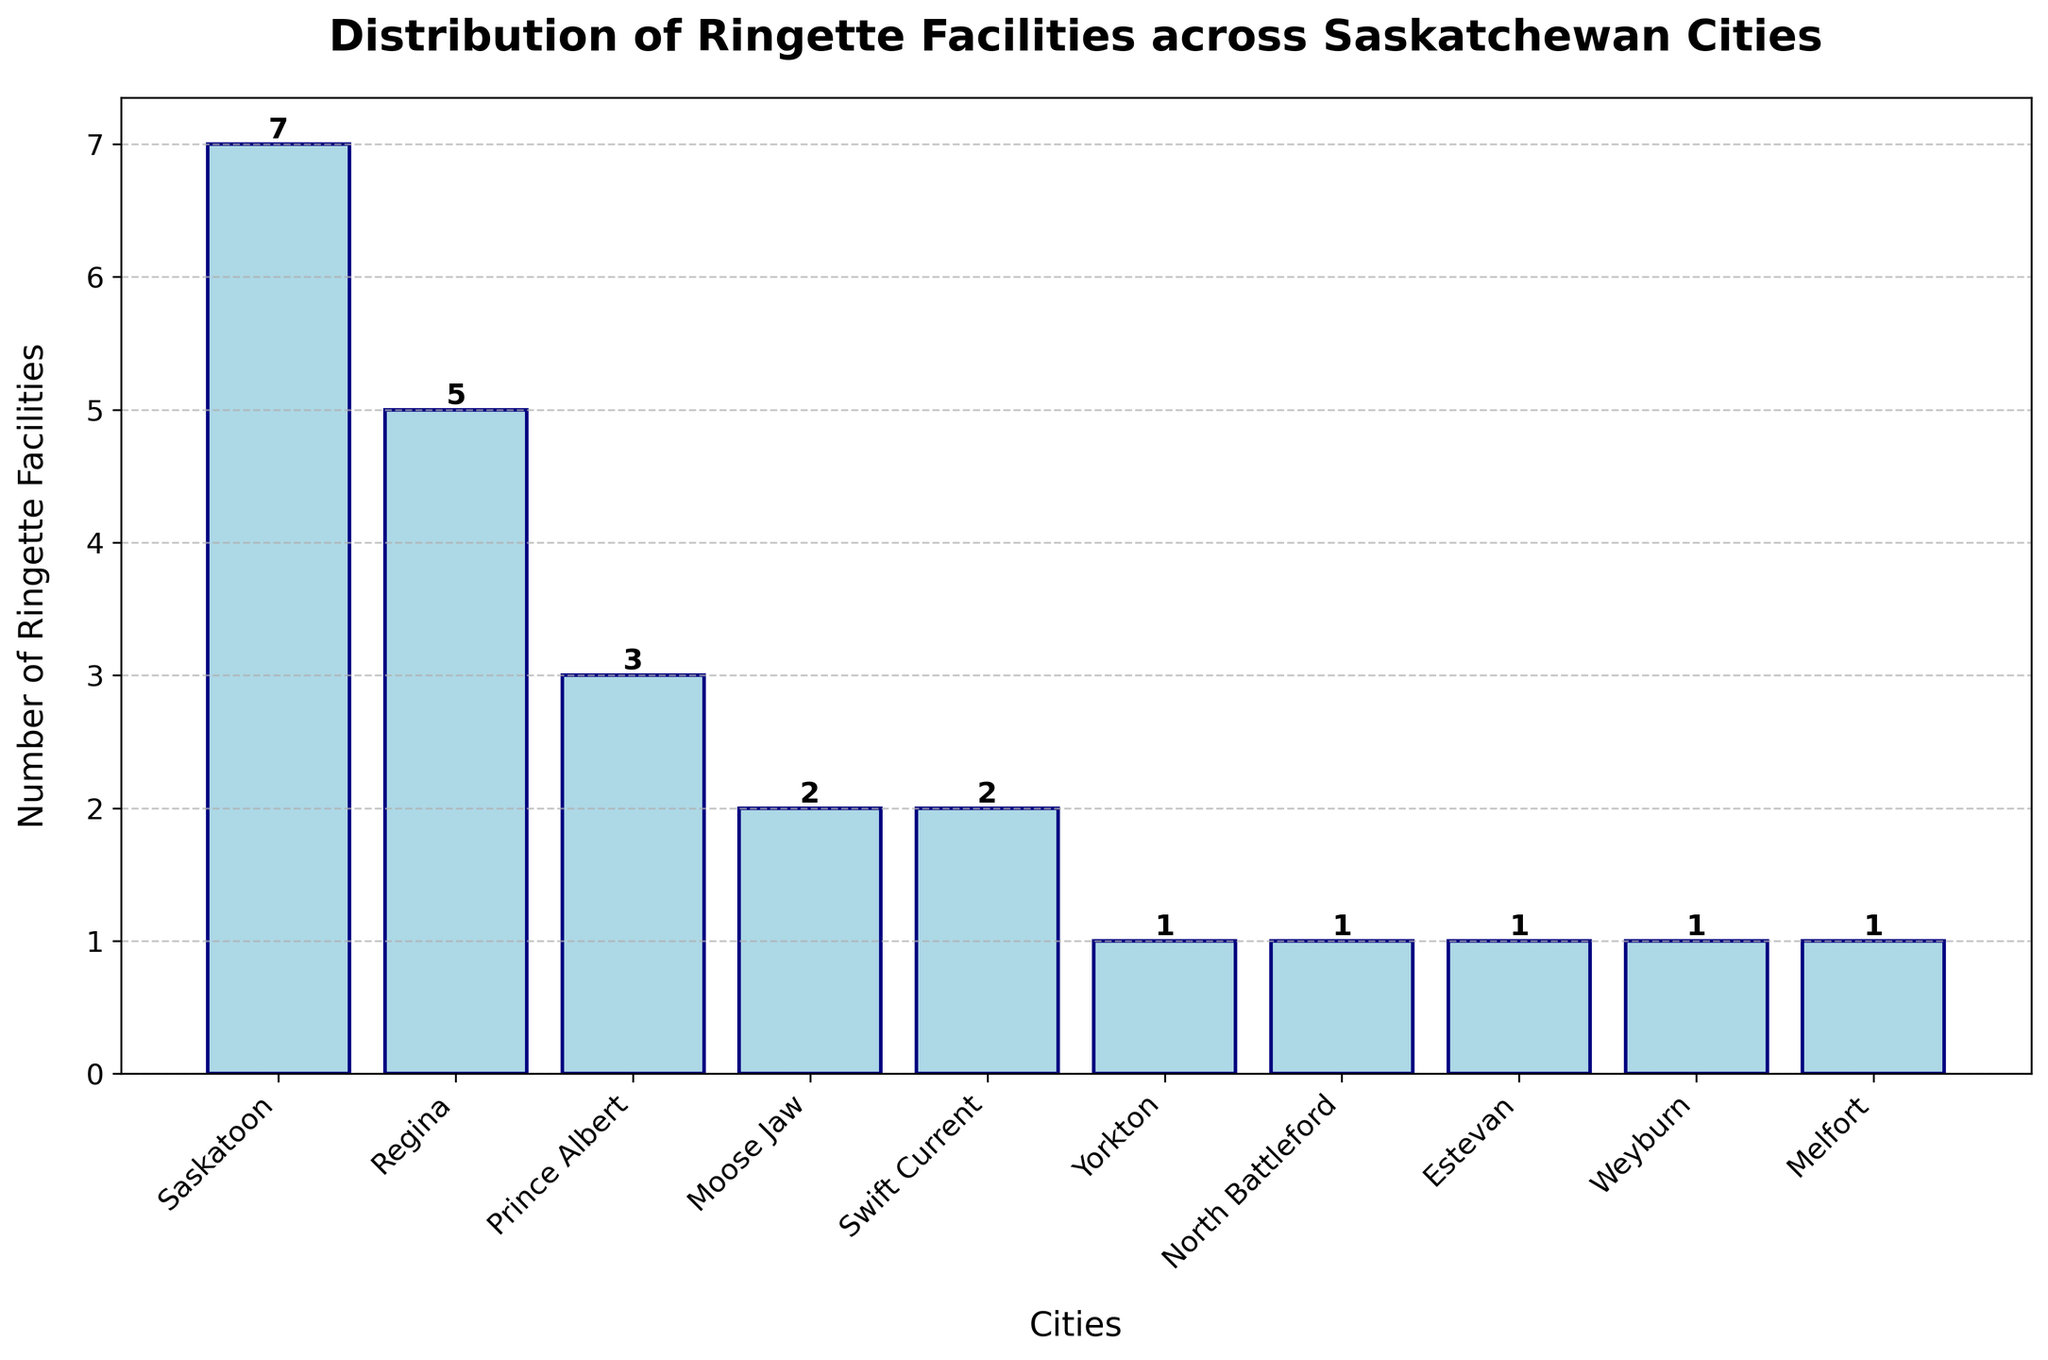How many cities have only one ringette facility? To determine how many cities have only one ringette facility, we look at the height of the bars that represent 1 on the y-axis. There are five bars corresponding to Yorkton, North Battleford, Estevan, Weyburn, and Melfort.
Answer: 5 Which city has the most ringette facilities, and how many does it have? The tallest bar represents the city with the most ringette facilities. The tallest bar corresponds to Saskatoon, which has a height of 7 facilities.
Answer: Saskatoon, 7 Compare the number of ringette facilities in Regina and Prince Albert. Which city has more, and by how many? Regina has 5 facilities as shown by its bar. Prince Albert has 3 facilities as indicated by its bar. The difference in the number of facilities is 5 - 3 = 2, with Regina having 2 more facilities than Prince Albert.
Answer: Regina by 2 What is the average number of ringette facilities across all the cities? To find the average number of facilities, add up the number of facilities across all cities and divide by the number of cities. The sum is 7+5+3+2+2+1+1+1+1+1 = 24. There are 10 cities. So the average is 24 / 10 = 2.4.
Answer: 2.4 Which cities have an equal number of ringette facilities? To find cities with equal numbers, look for bars of the same height. Moose Jaw and Swift Current both have bars at height 2. Yorkton, North Battleford, Estevan, Weyburn, and Melfort have bars at height 1.
Answer: Moose Jaw and Swift Current; Yorkton, North Battleford, Estevan, Weyburn, and Melfort What is the total number of ringette facilities in cities other than Saskatoon? Sum the facilities in all the cities except Saskatoon. The total is 5 (Regina) + 3 (Prince Albert) + 2 (Moose Jaw) + 2 (Swift Current) + 1 (Yorkton) + 1 (North Battleford) + 1 (Estevan) + 1 (Weyburn) + 1 (Melfort), which equals 17.
Answer: 17 If you combine the number of facilities in Regina and Saskatoon, what fraction of the total number of facilities in the dataset is this? First, find the total number of facilities in Regina and Saskatoon, which is 5 + 7 = 12. Then, find the total number of facilities in all cities, which is 24. The fraction is 12 / 24 = 1/2.
Answer: 1/2 What is the second highest number of ringette facilities among the cities, and which city has this number? After Saskatoon, which has 7 facilities, the next tallest bar is Regina's with 5 facilities.
Answer: Regina with 5 Which bar has the same color as the one representing Yorkton and what is the significance of this? All bars in the chart have the same color, light blue, representing the number of ringette facilities in various cities. This uniform color signifies that the bars only differ in the number of facilities they represent.
Answer: All bars; color uniformity 